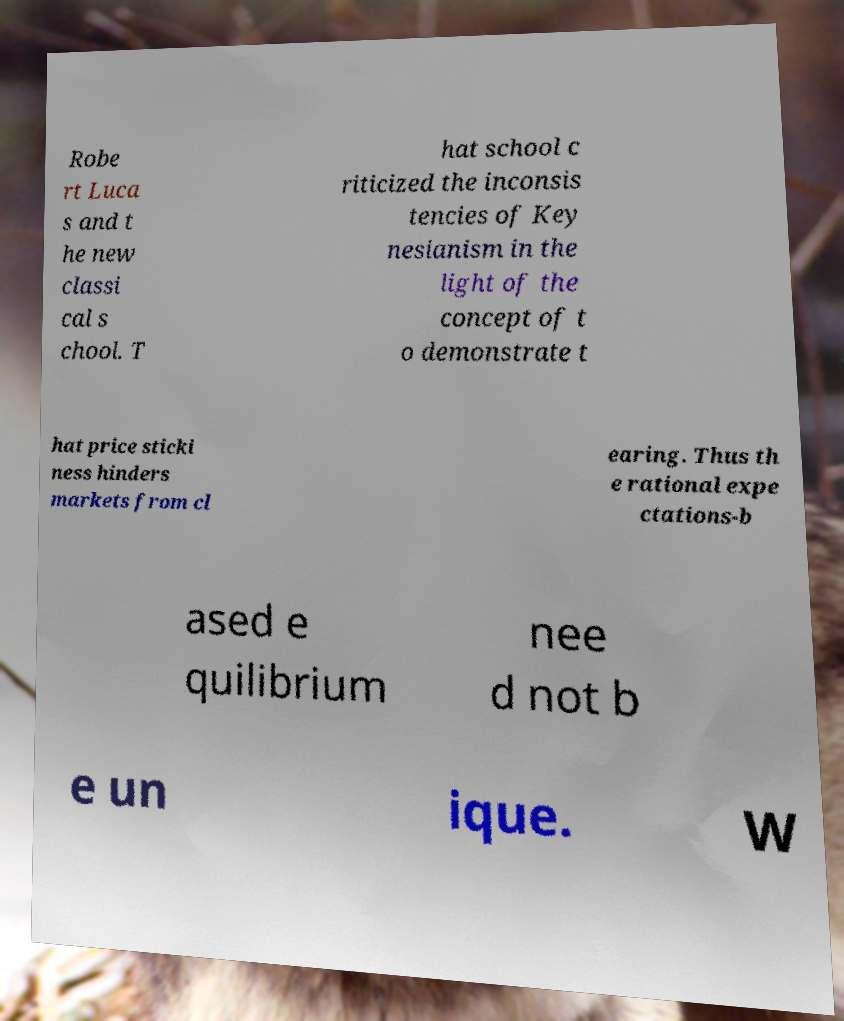For documentation purposes, I need the text within this image transcribed. Could you provide that? Robe rt Luca s and t he new classi cal s chool. T hat school c riticized the inconsis tencies of Key nesianism in the light of the concept of t o demonstrate t hat price sticki ness hinders markets from cl earing. Thus th e rational expe ctations-b ased e quilibrium nee d not b e un ique. W 